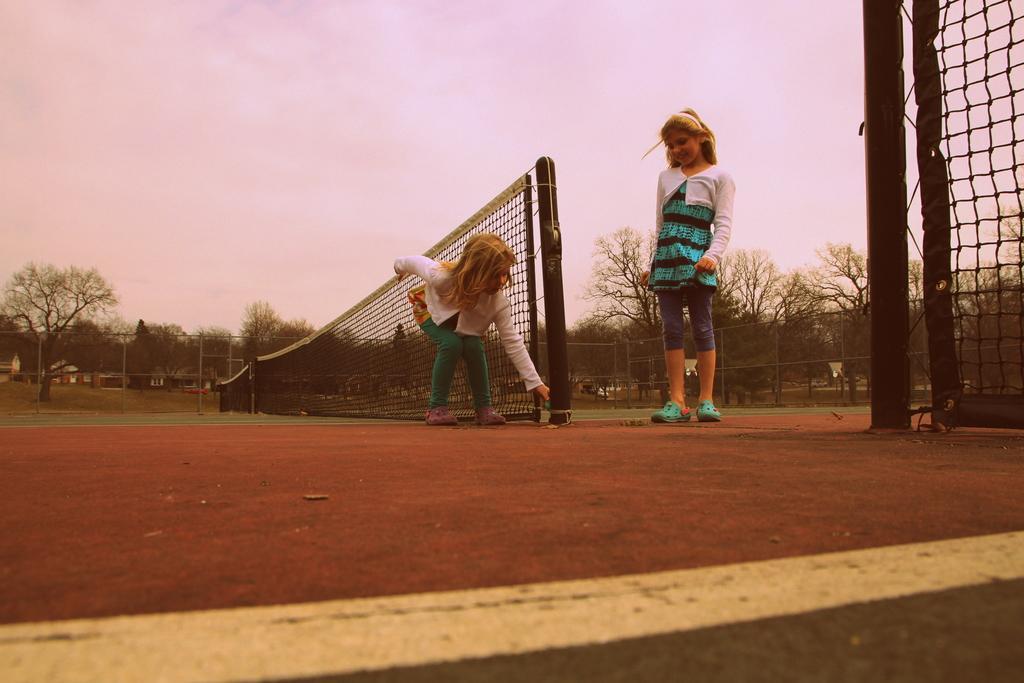Could you give a brief overview of what you see in this image? In this image I can see tennis courts, nets, number of trees, fencing, white line over here and I can also see two girls. 